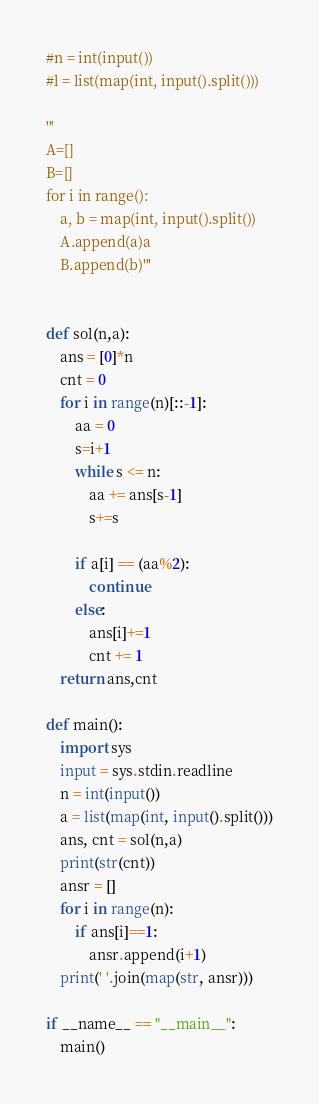Convert code to text. <code><loc_0><loc_0><loc_500><loc_500><_Python_>#n = int(input())
#l = list(map(int, input().split()))

'''
A=[]
B=[]
for i in range():
    a, b = map(int, input().split())
    A.append(a)a
    B.append(b)'''


def sol(n,a):
    ans = [0]*n
    cnt = 0
    for i in range(n)[::-1]:
        aa = 0
        s=i+1
        while s <= n:
            aa += ans[s-1]
            s+=s

        if a[i] == (aa%2):
            continue
        else:
            ans[i]+=1
            cnt += 1
    return ans,cnt
    
def main():
    import sys
    input = sys.stdin.readline
    n = int(input())
    a = list(map(int, input().split()))
    ans, cnt = sol(n,a)
    print(str(cnt))
    ansr = []
    for i in range(n):
        if ans[i]==1:
            ansr.append(i+1)
    print(' '.join(map(str, ansr)))

if __name__ == "__main__":
    main()
</code> 